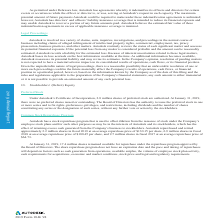According to Autodesk's financial document, How is basic net loss per share calculated? Based on the financial document, the answer is Basic net loss per share is computed using the weighted average number of shares of common stock outstanding for the period, excluding stock options and restricted stock units.. Also, Why does the computation of diluted net loss per share does not include shares that are anti-dilutive under the treasury stock method? Based on the financial document, the answer is The computation of diluted net loss per share does not include shares that are anti-dilutive under the treasury stock method. Also, What is the basic net loss per share in 2017? Based on the financial document, the answer is $(2.61). Also, can you calculate: What is the change in the basic net loss per share from 2018 to 2019? Based on the calculation: 2.58-0.37, the result is 2.21. The key data points involved are: 0.37, 2.58. Also, can you calculate: What is the change in the numerator net loss from 2018 to 2019? Based on the calculation: 566.9-80.8, the result is 486.1 (in millions). The key data points involved are: 566.9, 80.8. Also, can you calculate: How much was the average basic net loss per share from 2017 to 2019? To answer this question, I need to perform calculations using the financial data. The calculation is: (0.37+2.58+2.61)/3 , which equals 1.85. The key data points involved are: 0.37, 2.58, 2.61. 